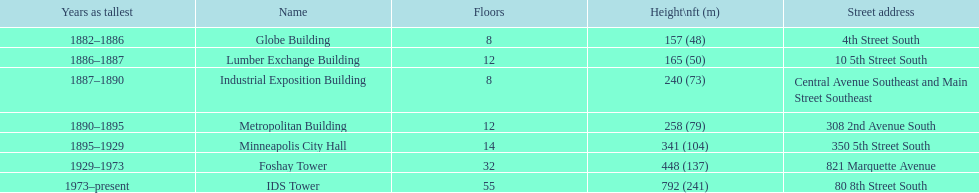How tall is it to the top of the ids tower in feet? 792. 